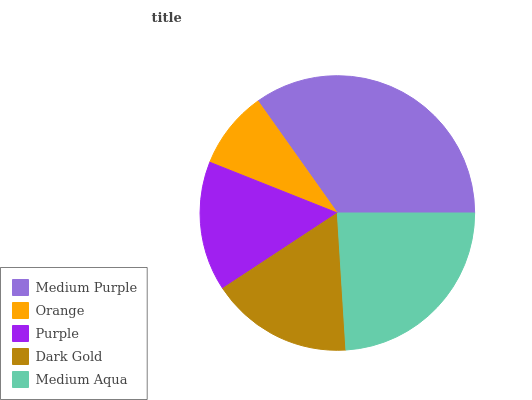Is Orange the minimum?
Answer yes or no. Yes. Is Medium Purple the maximum?
Answer yes or no. Yes. Is Purple the minimum?
Answer yes or no. No. Is Purple the maximum?
Answer yes or no. No. Is Purple greater than Orange?
Answer yes or no. Yes. Is Orange less than Purple?
Answer yes or no. Yes. Is Orange greater than Purple?
Answer yes or no. No. Is Purple less than Orange?
Answer yes or no. No. Is Dark Gold the high median?
Answer yes or no. Yes. Is Dark Gold the low median?
Answer yes or no. Yes. Is Medium Aqua the high median?
Answer yes or no. No. Is Medium Purple the low median?
Answer yes or no. No. 